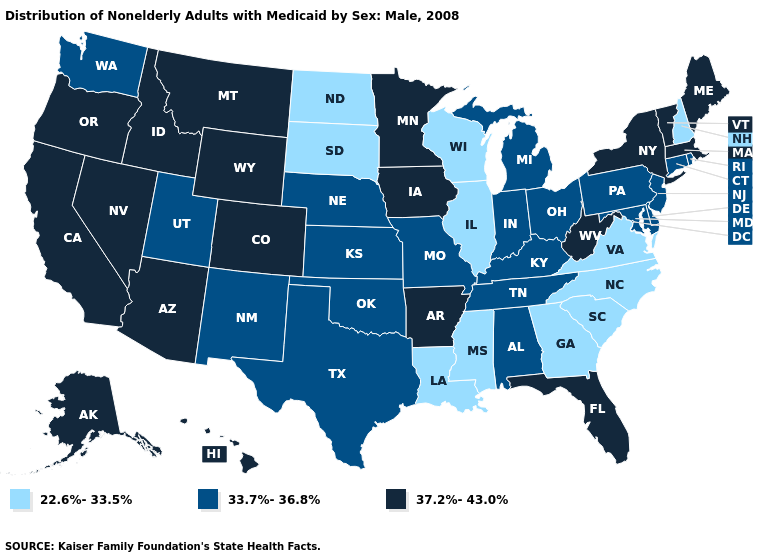Among the states that border New Hampshire , which have the highest value?
Answer briefly. Maine, Massachusetts, Vermont. What is the value of California?
Concise answer only. 37.2%-43.0%. Name the states that have a value in the range 22.6%-33.5%?
Give a very brief answer. Georgia, Illinois, Louisiana, Mississippi, New Hampshire, North Carolina, North Dakota, South Carolina, South Dakota, Virginia, Wisconsin. Name the states that have a value in the range 22.6%-33.5%?
Write a very short answer. Georgia, Illinois, Louisiana, Mississippi, New Hampshire, North Carolina, North Dakota, South Carolina, South Dakota, Virginia, Wisconsin. Name the states that have a value in the range 37.2%-43.0%?
Be succinct. Alaska, Arizona, Arkansas, California, Colorado, Florida, Hawaii, Idaho, Iowa, Maine, Massachusetts, Minnesota, Montana, Nevada, New York, Oregon, Vermont, West Virginia, Wyoming. What is the lowest value in states that border North Dakota?
Be succinct. 22.6%-33.5%. What is the value of Maine?
Concise answer only. 37.2%-43.0%. Does the first symbol in the legend represent the smallest category?
Short answer required. Yes. Does Utah have the highest value in the USA?
Keep it brief. No. Name the states that have a value in the range 22.6%-33.5%?
Quick response, please. Georgia, Illinois, Louisiana, Mississippi, New Hampshire, North Carolina, North Dakota, South Carolina, South Dakota, Virginia, Wisconsin. What is the value of Wyoming?
Concise answer only. 37.2%-43.0%. What is the value of Kentucky?
Quick response, please. 33.7%-36.8%. What is the value of Texas?
Answer briefly. 33.7%-36.8%. Name the states that have a value in the range 37.2%-43.0%?
Be succinct. Alaska, Arizona, Arkansas, California, Colorado, Florida, Hawaii, Idaho, Iowa, Maine, Massachusetts, Minnesota, Montana, Nevada, New York, Oregon, Vermont, West Virginia, Wyoming. Name the states that have a value in the range 22.6%-33.5%?
Quick response, please. Georgia, Illinois, Louisiana, Mississippi, New Hampshire, North Carolina, North Dakota, South Carolina, South Dakota, Virginia, Wisconsin. 